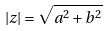Convert formula to latex. <formula><loc_0><loc_0><loc_500><loc_500>| z | = \sqrt { a ^ { 2 } + b ^ { 2 } }</formula> 